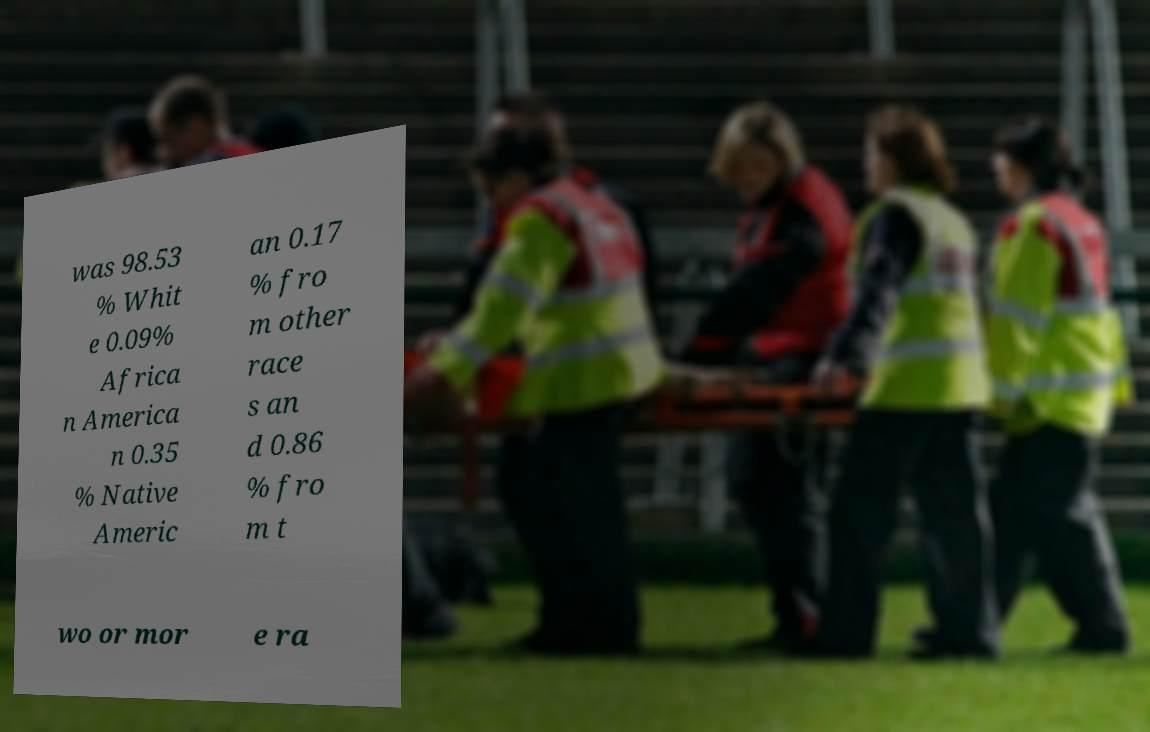Can you read and provide the text displayed in the image?This photo seems to have some interesting text. Can you extract and type it out for me? was 98.53 % Whit e 0.09% Africa n America n 0.35 % Native Americ an 0.17 % fro m other race s an d 0.86 % fro m t wo or mor e ra 